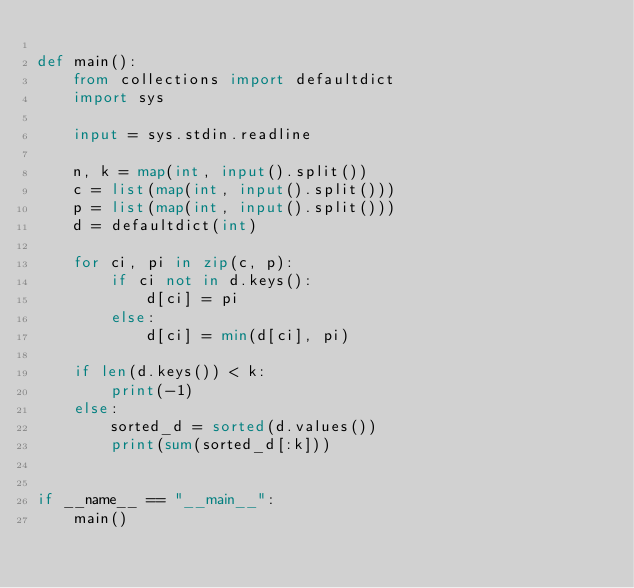Convert code to text. <code><loc_0><loc_0><loc_500><loc_500><_Python_>
def main():
    from collections import defaultdict
    import sys

    input = sys.stdin.readline

    n, k = map(int, input().split())
    c = list(map(int, input().split()))
    p = list(map(int, input().split()))
    d = defaultdict(int)

    for ci, pi in zip(c, p):
        if ci not in d.keys():
            d[ci] = pi
        else:
            d[ci] = min(d[ci], pi)
    
    if len(d.keys()) < k:
        print(-1)
    else:
        sorted_d = sorted(d.values())
        print(sum(sorted_d[:k]))


if __name__ == "__main__":
    main()
</code> 